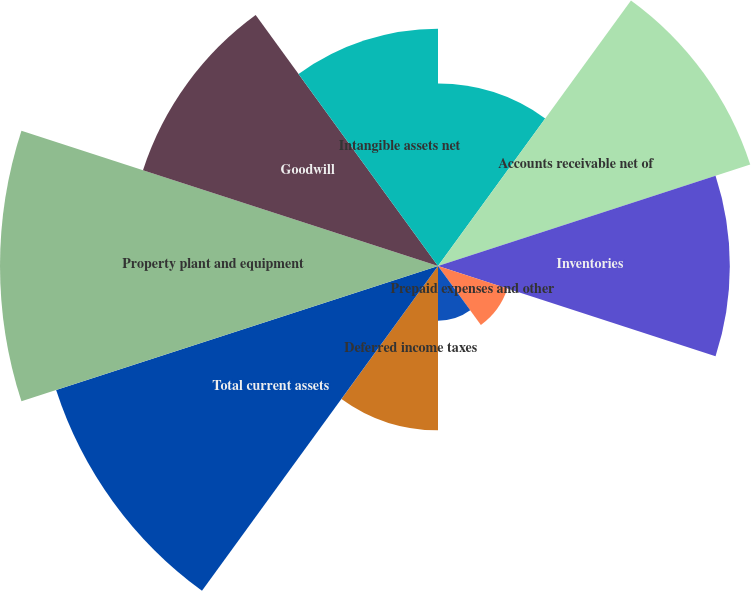Convert chart. <chart><loc_0><loc_0><loc_500><loc_500><pie_chart><fcel>Cash and cash equivalents<fcel>Accounts receivable net of<fcel>Inventories<fcel>Prepaid expenses and other<fcel>Federal and state income taxes<fcel>Deferred income taxes<fcel>Total current assets<fcel>Property plant and equipment<fcel>Goodwill<fcel>Intangible assets net<nl><fcel>7.35%<fcel>13.23%<fcel>11.76%<fcel>2.94%<fcel>2.21%<fcel>6.62%<fcel>16.18%<fcel>17.65%<fcel>12.5%<fcel>9.56%<nl></chart> 